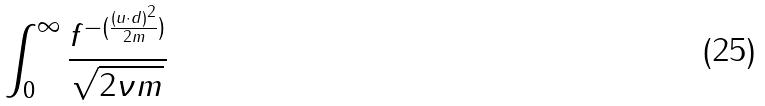<formula> <loc_0><loc_0><loc_500><loc_500>\int _ { 0 } ^ { \infty } \frac { f ^ { - ( \frac { ( u \cdot d ) ^ { 2 } } { 2 m } ) } } { \sqrt { 2 \nu m } }</formula> 